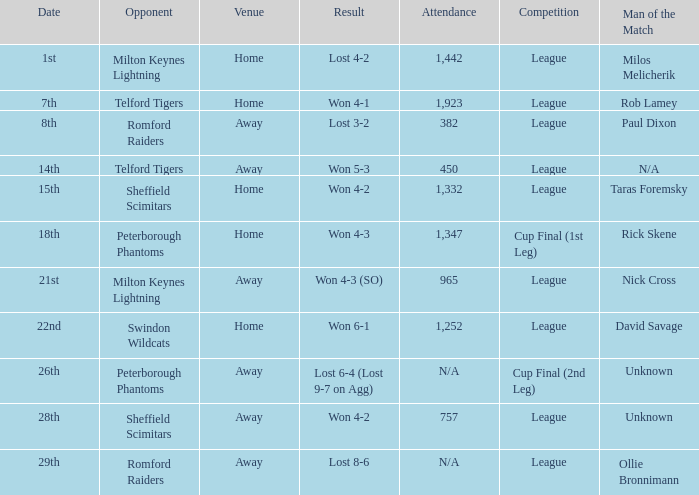What was the consequence on the 26th? Lost 6-4 (Lost 9-7 on Agg). 